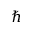<formula> <loc_0><loc_0><loc_500><loc_500>\hbar</formula> 